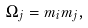<formula> <loc_0><loc_0><loc_500><loc_500>\Omega _ { j } = m _ { i } m _ { j } ,</formula> 